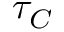<formula> <loc_0><loc_0><loc_500><loc_500>\tau _ { C }</formula> 